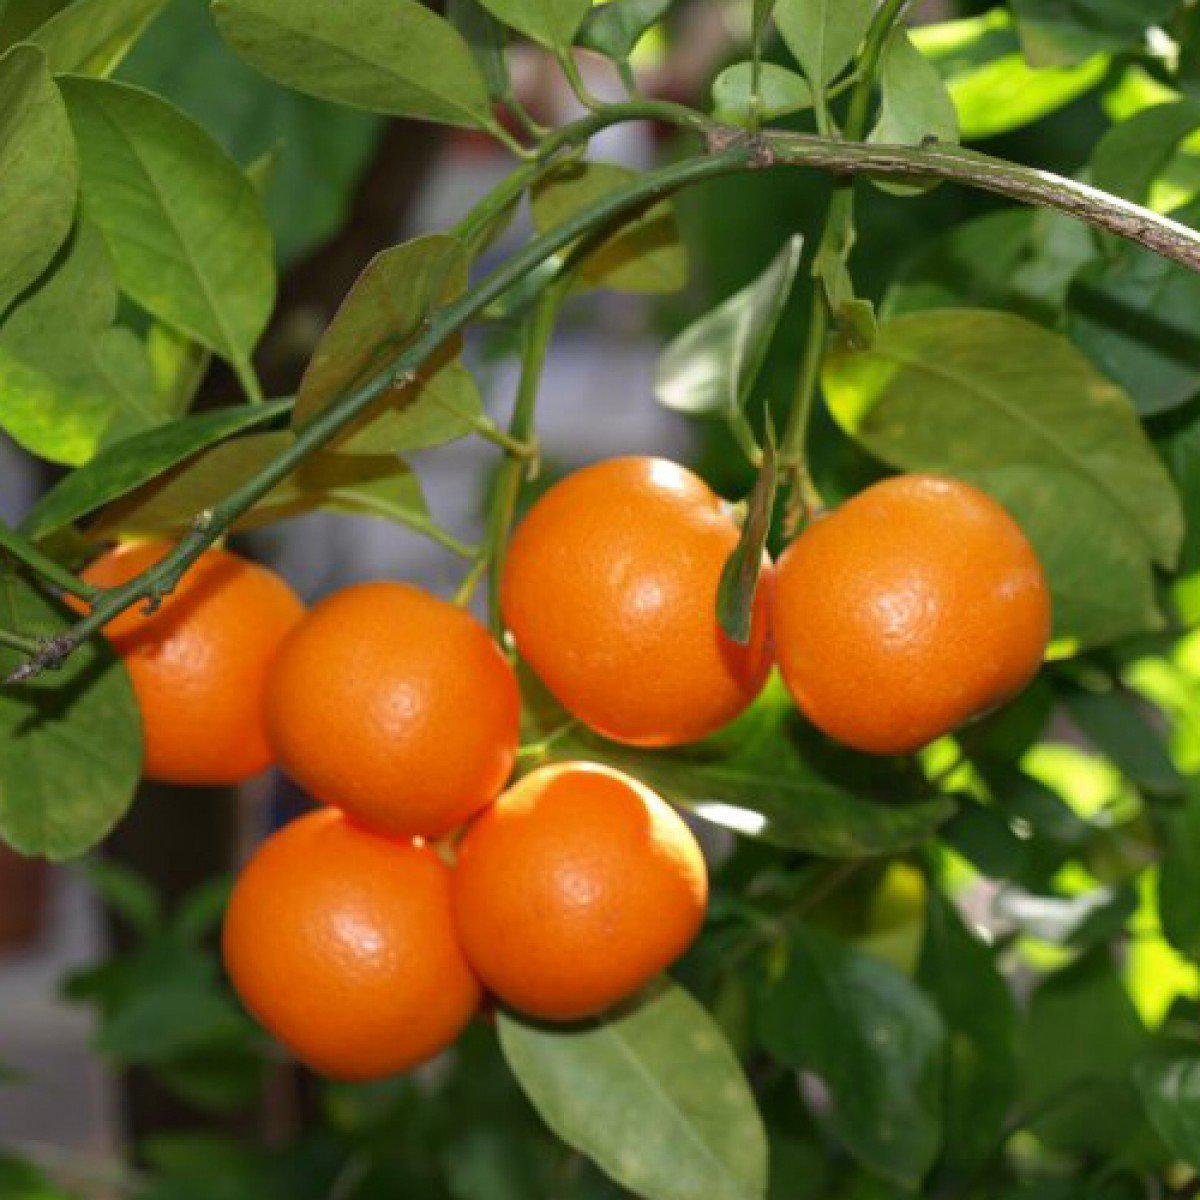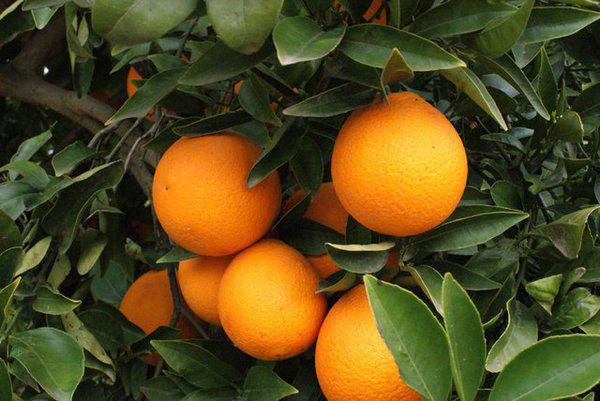The first image is the image on the left, the second image is the image on the right. Given the left and right images, does the statement "An orange tree is flowering." hold true? Answer yes or no. No. 